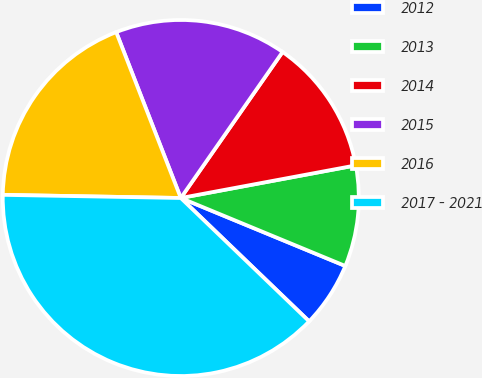Convert chart to OTSL. <chart><loc_0><loc_0><loc_500><loc_500><pie_chart><fcel>2012<fcel>2013<fcel>2014<fcel>2015<fcel>2016<fcel>2017 - 2021<nl><fcel>5.95%<fcel>9.17%<fcel>12.38%<fcel>15.6%<fcel>18.81%<fcel>38.1%<nl></chart> 